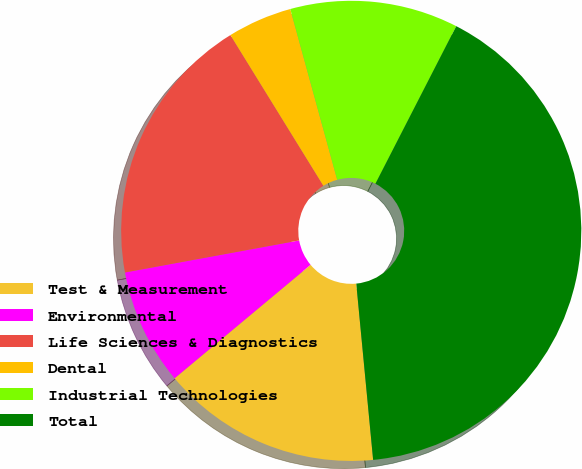Convert chart to OTSL. <chart><loc_0><loc_0><loc_500><loc_500><pie_chart><fcel>Test & Measurement<fcel>Environmental<fcel>Life Sciences & Diagnostics<fcel>Dental<fcel>Industrial Technologies<fcel>Total<nl><fcel>15.45%<fcel>8.17%<fcel>19.09%<fcel>4.53%<fcel>11.81%<fcel>40.93%<nl></chart> 